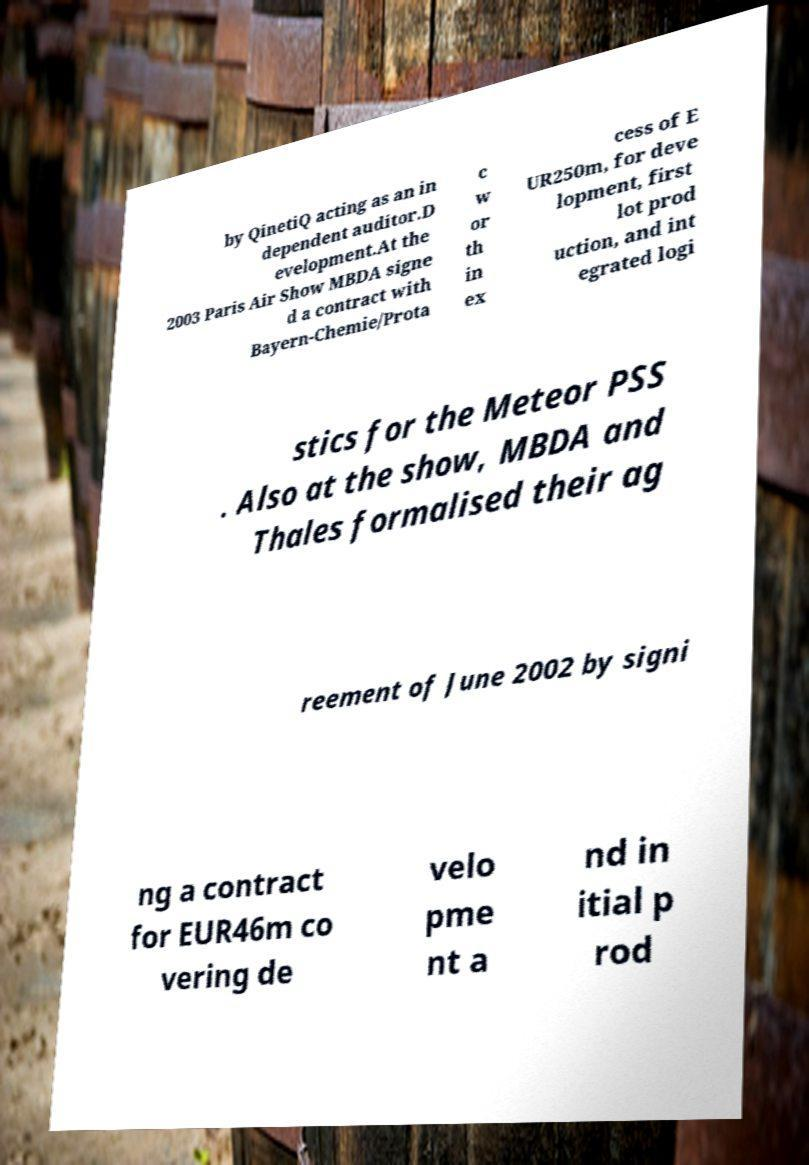Please read and relay the text visible in this image. What does it say? by QinetiQ acting as an in dependent auditor.D evelopment.At the 2003 Paris Air Show MBDA signe d a contract with Bayern-Chemie/Prota c w or th in ex cess of E UR250m, for deve lopment, first lot prod uction, and int egrated logi stics for the Meteor PSS . Also at the show, MBDA and Thales formalised their ag reement of June 2002 by signi ng a contract for EUR46m co vering de velo pme nt a nd in itial p rod 